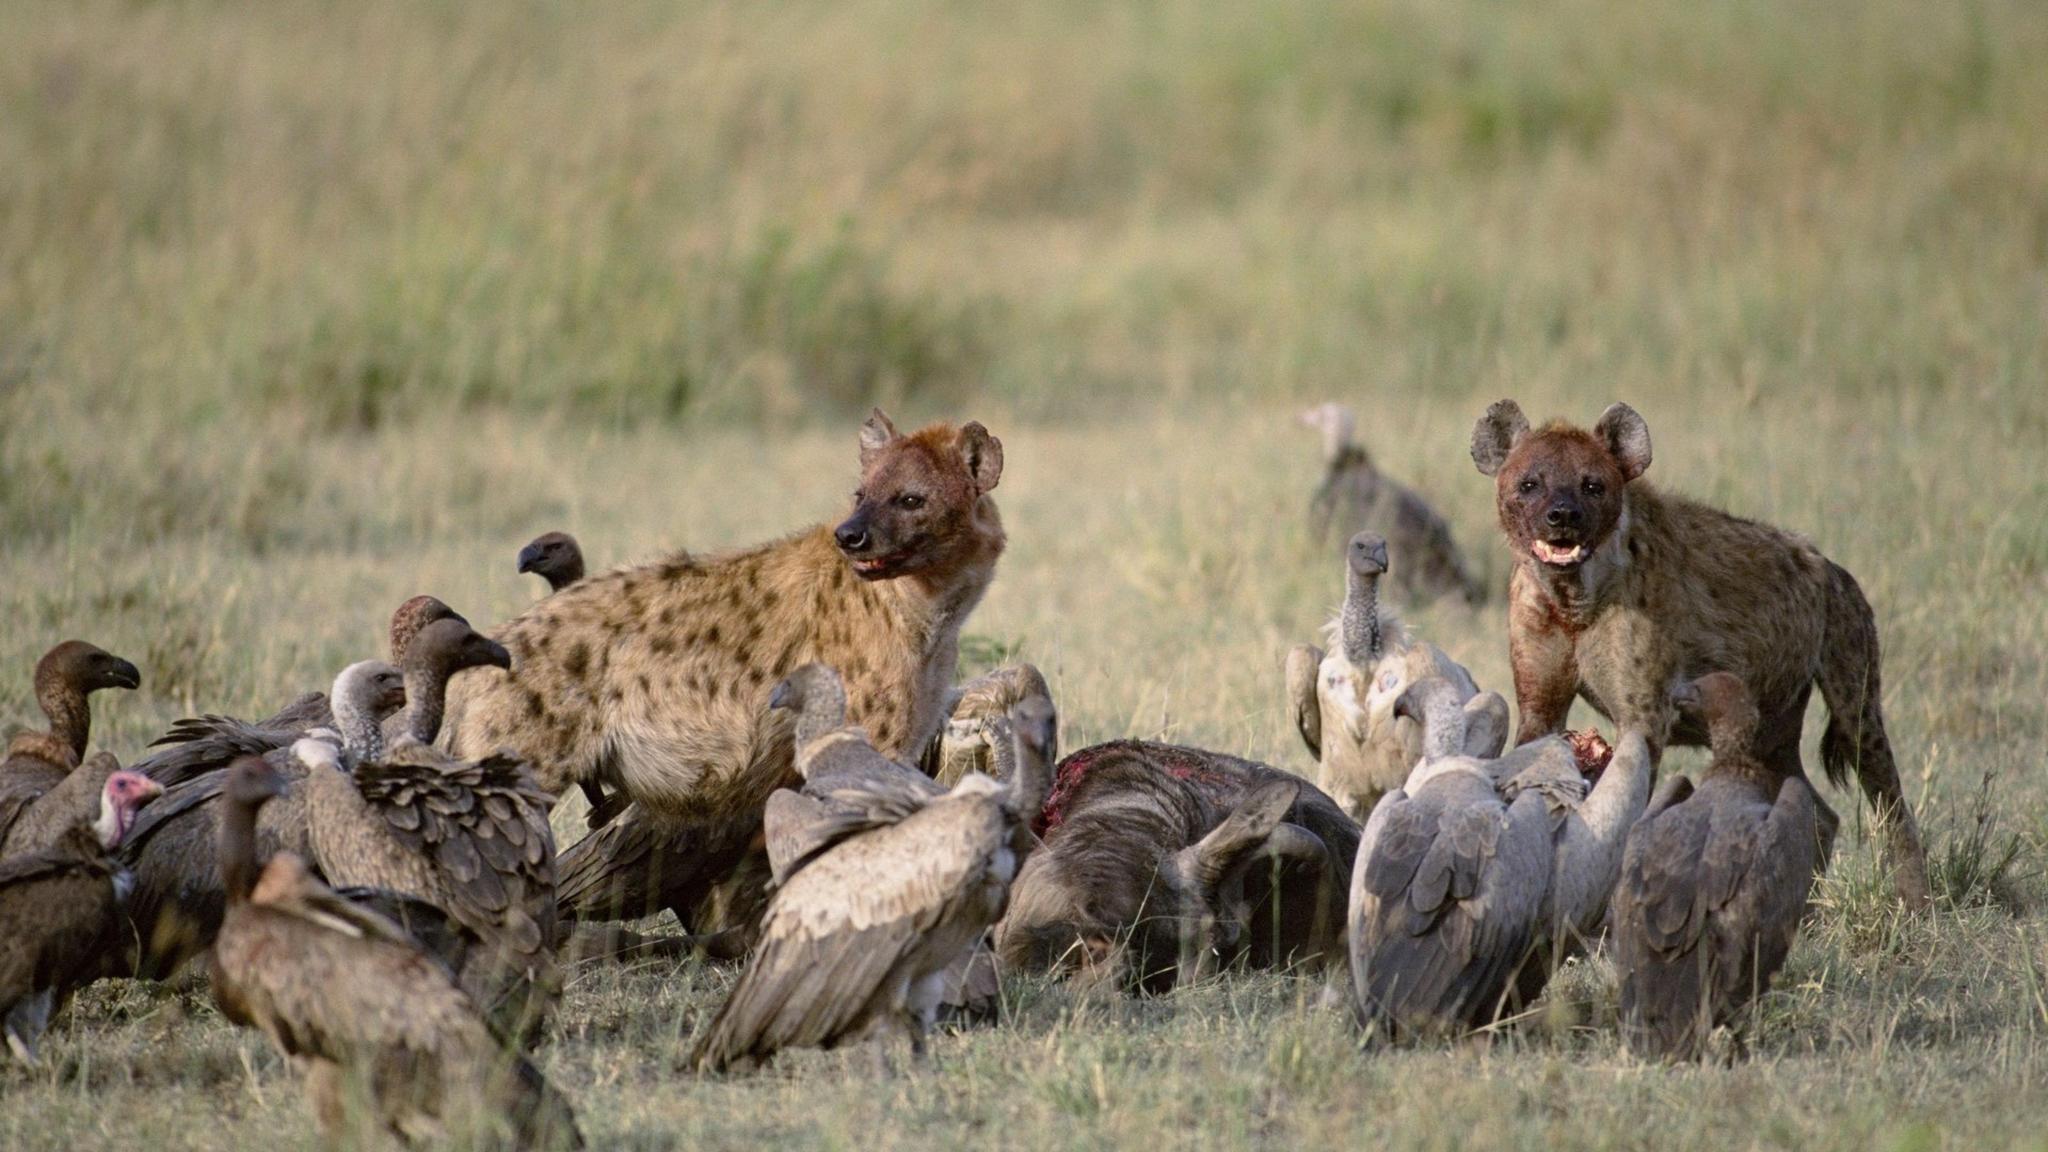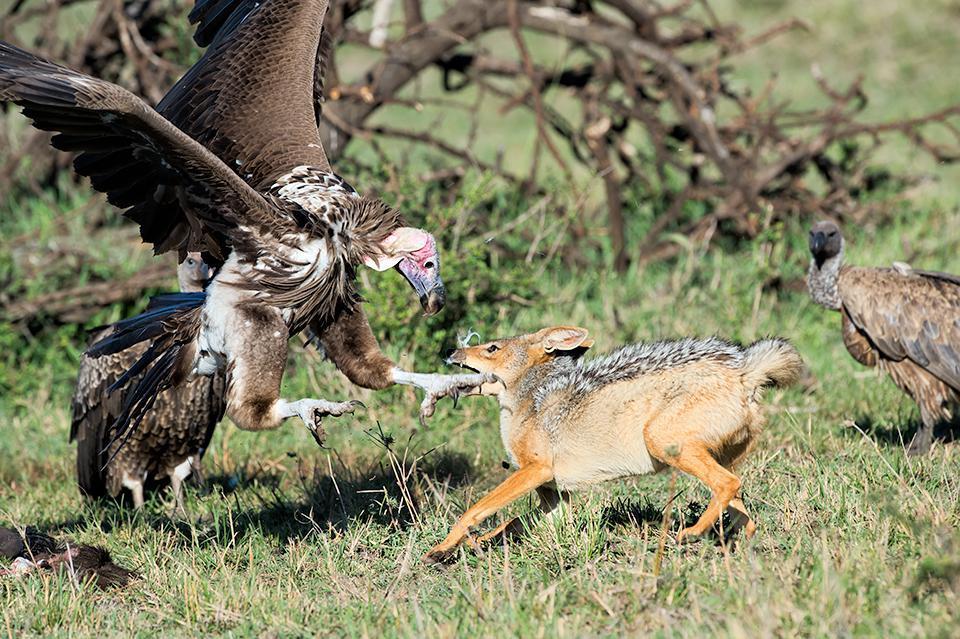The first image is the image on the left, the second image is the image on the right. Given the left and right images, does the statement "there is at least one hyena in the image on the left" hold true? Answer yes or no. Yes. The first image is the image on the left, the second image is the image on the right. Evaluate the accuracy of this statement regarding the images: "There are a total of two hyena in the images.". Is it true? Answer yes or no. Yes. 